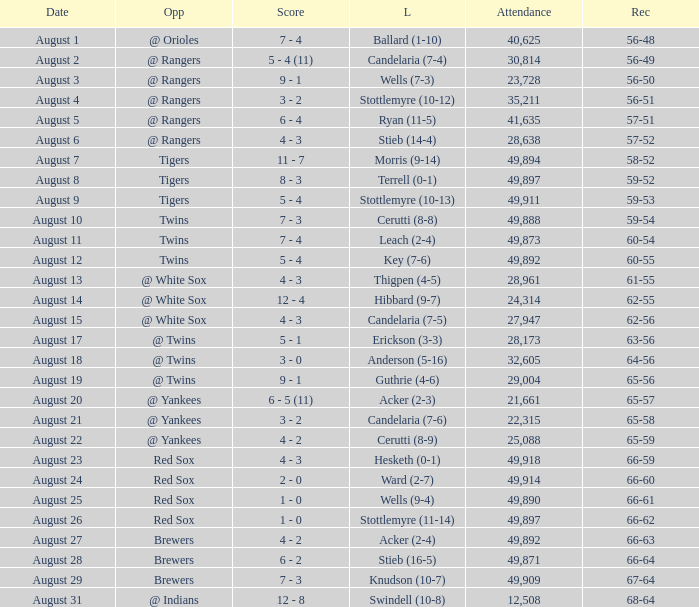What was the Attendance high on August 28? 49871.0. 